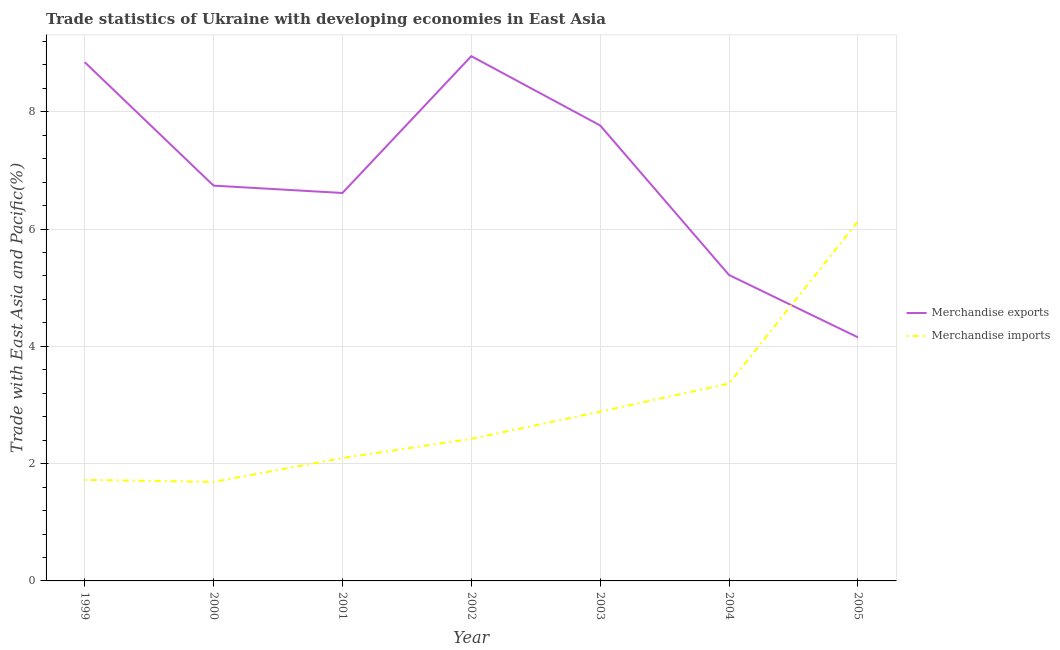How many different coloured lines are there?
Provide a short and direct response. 2. Is the number of lines equal to the number of legend labels?
Keep it short and to the point. Yes. What is the merchandise exports in 2005?
Keep it short and to the point. 4.15. Across all years, what is the maximum merchandise imports?
Your answer should be very brief. 6.13. Across all years, what is the minimum merchandise exports?
Make the answer very short. 4.15. In which year was the merchandise imports maximum?
Your response must be concise. 2005. What is the total merchandise imports in the graph?
Keep it short and to the point. 20.31. What is the difference between the merchandise exports in 2000 and that in 2004?
Offer a terse response. 1.52. What is the difference between the merchandise exports in 2003 and the merchandise imports in 2005?
Provide a short and direct response. 1.64. What is the average merchandise imports per year?
Offer a terse response. 2.9. In the year 2002, what is the difference between the merchandise exports and merchandise imports?
Your answer should be compact. 6.53. What is the ratio of the merchandise imports in 2001 to that in 2004?
Offer a very short reply. 0.62. Is the merchandise imports in 1999 less than that in 2000?
Keep it short and to the point. No. Is the difference between the merchandise exports in 1999 and 2001 greater than the difference between the merchandise imports in 1999 and 2001?
Provide a short and direct response. Yes. What is the difference between the highest and the second highest merchandise imports?
Your answer should be compact. 2.76. What is the difference between the highest and the lowest merchandise imports?
Offer a very short reply. 4.44. Is the sum of the merchandise imports in 2000 and 2003 greater than the maximum merchandise exports across all years?
Provide a succinct answer. No. Are the values on the major ticks of Y-axis written in scientific E-notation?
Offer a very short reply. No. Where does the legend appear in the graph?
Provide a short and direct response. Center right. How are the legend labels stacked?
Offer a very short reply. Vertical. What is the title of the graph?
Give a very brief answer. Trade statistics of Ukraine with developing economies in East Asia. What is the label or title of the Y-axis?
Your answer should be very brief. Trade with East Asia and Pacific(%). What is the Trade with East Asia and Pacific(%) of Merchandise exports in 1999?
Your answer should be very brief. 8.85. What is the Trade with East Asia and Pacific(%) of Merchandise imports in 1999?
Give a very brief answer. 1.72. What is the Trade with East Asia and Pacific(%) in Merchandise exports in 2000?
Give a very brief answer. 6.74. What is the Trade with East Asia and Pacific(%) in Merchandise imports in 2000?
Your answer should be compact. 1.69. What is the Trade with East Asia and Pacific(%) of Merchandise exports in 2001?
Your response must be concise. 6.62. What is the Trade with East Asia and Pacific(%) in Merchandise imports in 2001?
Your answer should be compact. 2.1. What is the Trade with East Asia and Pacific(%) of Merchandise exports in 2002?
Provide a short and direct response. 8.95. What is the Trade with East Asia and Pacific(%) of Merchandise imports in 2002?
Make the answer very short. 2.42. What is the Trade with East Asia and Pacific(%) in Merchandise exports in 2003?
Ensure brevity in your answer.  7.77. What is the Trade with East Asia and Pacific(%) in Merchandise imports in 2003?
Offer a very short reply. 2.89. What is the Trade with East Asia and Pacific(%) in Merchandise exports in 2004?
Your response must be concise. 5.22. What is the Trade with East Asia and Pacific(%) of Merchandise imports in 2004?
Keep it short and to the point. 3.37. What is the Trade with East Asia and Pacific(%) in Merchandise exports in 2005?
Keep it short and to the point. 4.15. What is the Trade with East Asia and Pacific(%) of Merchandise imports in 2005?
Keep it short and to the point. 6.13. Across all years, what is the maximum Trade with East Asia and Pacific(%) in Merchandise exports?
Offer a terse response. 8.95. Across all years, what is the maximum Trade with East Asia and Pacific(%) in Merchandise imports?
Make the answer very short. 6.13. Across all years, what is the minimum Trade with East Asia and Pacific(%) in Merchandise exports?
Your answer should be very brief. 4.15. Across all years, what is the minimum Trade with East Asia and Pacific(%) of Merchandise imports?
Ensure brevity in your answer.  1.69. What is the total Trade with East Asia and Pacific(%) in Merchandise exports in the graph?
Your answer should be compact. 48.29. What is the total Trade with East Asia and Pacific(%) in Merchandise imports in the graph?
Your answer should be very brief. 20.31. What is the difference between the Trade with East Asia and Pacific(%) of Merchandise exports in 1999 and that in 2000?
Ensure brevity in your answer.  2.11. What is the difference between the Trade with East Asia and Pacific(%) of Merchandise imports in 1999 and that in 2000?
Make the answer very short. 0.03. What is the difference between the Trade with East Asia and Pacific(%) of Merchandise exports in 1999 and that in 2001?
Give a very brief answer. 2.23. What is the difference between the Trade with East Asia and Pacific(%) of Merchandise imports in 1999 and that in 2001?
Offer a terse response. -0.37. What is the difference between the Trade with East Asia and Pacific(%) of Merchandise exports in 1999 and that in 2002?
Offer a terse response. -0.1. What is the difference between the Trade with East Asia and Pacific(%) of Merchandise imports in 1999 and that in 2002?
Provide a succinct answer. -0.7. What is the difference between the Trade with East Asia and Pacific(%) in Merchandise exports in 1999 and that in 2003?
Keep it short and to the point. 1.08. What is the difference between the Trade with East Asia and Pacific(%) in Merchandise imports in 1999 and that in 2003?
Ensure brevity in your answer.  -1.16. What is the difference between the Trade with East Asia and Pacific(%) of Merchandise exports in 1999 and that in 2004?
Provide a short and direct response. 3.63. What is the difference between the Trade with East Asia and Pacific(%) of Merchandise imports in 1999 and that in 2004?
Keep it short and to the point. -1.64. What is the difference between the Trade with East Asia and Pacific(%) of Merchandise exports in 1999 and that in 2005?
Your answer should be very brief. 4.69. What is the difference between the Trade with East Asia and Pacific(%) of Merchandise imports in 1999 and that in 2005?
Your response must be concise. -4.41. What is the difference between the Trade with East Asia and Pacific(%) in Merchandise imports in 2000 and that in 2001?
Provide a short and direct response. -0.41. What is the difference between the Trade with East Asia and Pacific(%) in Merchandise exports in 2000 and that in 2002?
Give a very brief answer. -2.21. What is the difference between the Trade with East Asia and Pacific(%) in Merchandise imports in 2000 and that in 2002?
Your answer should be compact. -0.73. What is the difference between the Trade with East Asia and Pacific(%) in Merchandise exports in 2000 and that in 2003?
Ensure brevity in your answer.  -1.03. What is the difference between the Trade with East Asia and Pacific(%) of Merchandise imports in 2000 and that in 2003?
Offer a very short reply. -1.2. What is the difference between the Trade with East Asia and Pacific(%) in Merchandise exports in 2000 and that in 2004?
Your answer should be very brief. 1.52. What is the difference between the Trade with East Asia and Pacific(%) of Merchandise imports in 2000 and that in 2004?
Your answer should be very brief. -1.68. What is the difference between the Trade with East Asia and Pacific(%) of Merchandise exports in 2000 and that in 2005?
Give a very brief answer. 2.59. What is the difference between the Trade with East Asia and Pacific(%) of Merchandise imports in 2000 and that in 2005?
Give a very brief answer. -4.44. What is the difference between the Trade with East Asia and Pacific(%) in Merchandise exports in 2001 and that in 2002?
Your answer should be very brief. -2.33. What is the difference between the Trade with East Asia and Pacific(%) of Merchandise imports in 2001 and that in 2002?
Give a very brief answer. -0.33. What is the difference between the Trade with East Asia and Pacific(%) in Merchandise exports in 2001 and that in 2003?
Your answer should be compact. -1.15. What is the difference between the Trade with East Asia and Pacific(%) of Merchandise imports in 2001 and that in 2003?
Give a very brief answer. -0.79. What is the difference between the Trade with East Asia and Pacific(%) of Merchandise exports in 2001 and that in 2004?
Provide a succinct answer. 1.4. What is the difference between the Trade with East Asia and Pacific(%) of Merchandise imports in 2001 and that in 2004?
Offer a terse response. -1.27. What is the difference between the Trade with East Asia and Pacific(%) of Merchandise exports in 2001 and that in 2005?
Offer a very short reply. 2.46. What is the difference between the Trade with East Asia and Pacific(%) of Merchandise imports in 2001 and that in 2005?
Make the answer very short. -4.04. What is the difference between the Trade with East Asia and Pacific(%) in Merchandise exports in 2002 and that in 2003?
Provide a succinct answer. 1.18. What is the difference between the Trade with East Asia and Pacific(%) of Merchandise imports in 2002 and that in 2003?
Provide a short and direct response. -0.46. What is the difference between the Trade with East Asia and Pacific(%) of Merchandise exports in 2002 and that in 2004?
Offer a very short reply. 3.73. What is the difference between the Trade with East Asia and Pacific(%) of Merchandise imports in 2002 and that in 2004?
Provide a short and direct response. -0.94. What is the difference between the Trade with East Asia and Pacific(%) of Merchandise exports in 2002 and that in 2005?
Offer a very short reply. 4.79. What is the difference between the Trade with East Asia and Pacific(%) in Merchandise imports in 2002 and that in 2005?
Provide a short and direct response. -3.71. What is the difference between the Trade with East Asia and Pacific(%) in Merchandise exports in 2003 and that in 2004?
Keep it short and to the point. 2.55. What is the difference between the Trade with East Asia and Pacific(%) of Merchandise imports in 2003 and that in 2004?
Provide a short and direct response. -0.48. What is the difference between the Trade with East Asia and Pacific(%) of Merchandise exports in 2003 and that in 2005?
Your response must be concise. 3.61. What is the difference between the Trade with East Asia and Pacific(%) in Merchandise imports in 2003 and that in 2005?
Provide a short and direct response. -3.24. What is the difference between the Trade with East Asia and Pacific(%) in Merchandise exports in 2004 and that in 2005?
Provide a short and direct response. 1.06. What is the difference between the Trade with East Asia and Pacific(%) in Merchandise imports in 2004 and that in 2005?
Provide a succinct answer. -2.76. What is the difference between the Trade with East Asia and Pacific(%) of Merchandise exports in 1999 and the Trade with East Asia and Pacific(%) of Merchandise imports in 2000?
Give a very brief answer. 7.16. What is the difference between the Trade with East Asia and Pacific(%) in Merchandise exports in 1999 and the Trade with East Asia and Pacific(%) in Merchandise imports in 2001?
Make the answer very short. 6.75. What is the difference between the Trade with East Asia and Pacific(%) of Merchandise exports in 1999 and the Trade with East Asia and Pacific(%) of Merchandise imports in 2002?
Offer a very short reply. 6.42. What is the difference between the Trade with East Asia and Pacific(%) of Merchandise exports in 1999 and the Trade with East Asia and Pacific(%) of Merchandise imports in 2003?
Keep it short and to the point. 5.96. What is the difference between the Trade with East Asia and Pacific(%) in Merchandise exports in 1999 and the Trade with East Asia and Pacific(%) in Merchandise imports in 2004?
Provide a succinct answer. 5.48. What is the difference between the Trade with East Asia and Pacific(%) of Merchandise exports in 1999 and the Trade with East Asia and Pacific(%) of Merchandise imports in 2005?
Keep it short and to the point. 2.72. What is the difference between the Trade with East Asia and Pacific(%) of Merchandise exports in 2000 and the Trade with East Asia and Pacific(%) of Merchandise imports in 2001?
Your answer should be very brief. 4.65. What is the difference between the Trade with East Asia and Pacific(%) of Merchandise exports in 2000 and the Trade with East Asia and Pacific(%) of Merchandise imports in 2002?
Provide a succinct answer. 4.32. What is the difference between the Trade with East Asia and Pacific(%) in Merchandise exports in 2000 and the Trade with East Asia and Pacific(%) in Merchandise imports in 2003?
Provide a succinct answer. 3.85. What is the difference between the Trade with East Asia and Pacific(%) in Merchandise exports in 2000 and the Trade with East Asia and Pacific(%) in Merchandise imports in 2004?
Your response must be concise. 3.37. What is the difference between the Trade with East Asia and Pacific(%) in Merchandise exports in 2000 and the Trade with East Asia and Pacific(%) in Merchandise imports in 2005?
Your answer should be compact. 0.61. What is the difference between the Trade with East Asia and Pacific(%) in Merchandise exports in 2001 and the Trade with East Asia and Pacific(%) in Merchandise imports in 2002?
Offer a very short reply. 4.19. What is the difference between the Trade with East Asia and Pacific(%) in Merchandise exports in 2001 and the Trade with East Asia and Pacific(%) in Merchandise imports in 2003?
Your answer should be compact. 3.73. What is the difference between the Trade with East Asia and Pacific(%) in Merchandise exports in 2001 and the Trade with East Asia and Pacific(%) in Merchandise imports in 2004?
Your response must be concise. 3.25. What is the difference between the Trade with East Asia and Pacific(%) in Merchandise exports in 2001 and the Trade with East Asia and Pacific(%) in Merchandise imports in 2005?
Your answer should be very brief. 0.48. What is the difference between the Trade with East Asia and Pacific(%) in Merchandise exports in 2002 and the Trade with East Asia and Pacific(%) in Merchandise imports in 2003?
Keep it short and to the point. 6.06. What is the difference between the Trade with East Asia and Pacific(%) of Merchandise exports in 2002 and the Trade with East Asia and Pacific(%) of Merchandise imports in 2004?
Your answer should be compact. 5.58. What is the difference between the Trade with East Asia and Pacific(%) of Merchandise exports in 2002 and the Trade with East Asia and Pacific(%) of Merchandise imports in 2005?
Provide a short and direct response. 2.82. What is the difference between the Trade with East Asia and Pacific(%) of Merchandise exports in 2003 and the Trade with East Asia and Pacific(%) of Merchandise imports in 2004?
Provide a succinct answer. 4.4. What is the difference between the Trade with East Asia and Pacific(%) of Merchandise exports in 2003 and the Trade with East Asia and Pacific(%) of Merchandise imports in 2005?
Your answer should be compact. 1.64. What is the difference between the Trade with East Asia and Pacific(%) of Merchandise exports in 2004 and the Trade with East Asia and Pacific(%) of Merchandise imports in 2005?
Make the answer very short. -0.91. What is the average Trade with East Asia and Pacific(%) in Merchandise exports per year?
Your answer should be very brief. 6.9. What is the average Trade with East Asia and Pacific(%) of Merchandise imports per year?
Your answer should be very brief. 2.9. In the year 1999, what is the difference between the Trade with East Asia and Pacific(%) of Merchandise exports and Trade with East Asia and Pacific(%) of Merchandise imports?
Provide a short and direct response. 7.12. In the year 2000, what is the difference between the Trade with East Asia and Pacific(%) in Merchandise exports and Trade with East Asia and Pacific(%) in Merchandise imports?
Provide a succinct answer. 5.05. In the year 2001, what is the difference between the Trade with East Asia and Pacific(%) in Merchandise exports and Trade with East Asia and Pacific(%) in Merchandise imports?
Ensure brevity in your answer.  4.52. In the year 2002, what is the difference between the Trade with East Asia and Pacific(%) in Merchandise exports and Trade with East Asia and Pacific(%) in Merchandise imports?
Offer a terse response. 6.53. In the year 2003, what is the difference between the Trade with East Asia and Pacific(%) of Merchandise exports and Trade with East Asia and Pacific(%) of Merchandise imports?
Provide a succinct answer. 4.88. In the year 2004, what is the difference between the Trade with East Asia and Pacific(%) in Merchandise exports and Trade with East Asia and Pacific(%) in Merchandise imports?
Your answer should be compact. 1.85. In the year 2005, what is the difference between the Trade with East Asia and Pacific(%) in Merchandise exports and Trade with East Asia and Pacific(%) in Merchandise imports?
Offer a very short reply. -1.98. What is the ratio of the Trade with East Asia and Pacific(%) in Merchandise exports in 1999 to that in 2000?
Offer a terse response. 1.31. What is the ratio of the Trade with East Asia and Pacific(%) of Merchandise imports in 1999 to that in 2000?
Your response must be concise. 1.02. What is the ratio of the Trade with East Asia and Pacific(%) of Merchandise exports in 1999 to that in 2001?
Your response must be concise. 1.34. What is the ratio of the Trade with East Asia and Pacific(%) in Merchandise imports in 1999 to that in 2001?
Provide a short and direct response. 0.82. What is the ratio of the Trade with East Asia and Pacific(%) of Merchandise imports in 1999 to that in 2002?
Give a very brief answer. 0.71. What is the ratio of the Trade with East Asia and Pacific(%) of Merchandise exports in 1999 to that in 2003?
Ensure brevity in your answer.  1.14. What is the ratio of the Trade with East Asia and Pacific(%) of Merchandise imports in 1999 to that in 2003?
Keep it short and to the point. 0.6. What is the ratio of the Trade with East Asia and Pacific(%) of Merchandise exports in 1999 to that in 2004?
Offer a very short reply. 1.7. What is the ratio of the Trade with East Asia and Pacific(%) of Merchandise imports in 1999 to that in 2004?
Your response must be concise. 0.51. What is the ratio of the Trade with East Asia and Pacific(%) of Merchandise exports in 1999 to that in 2005?
Keep it short and to the point. 2.13. What is the ratio of the Trade with East Asia and Pacific(%) of Merchandise imports in 1999 to that in 2005?
Offer a very short reply. 0.28. What is the ratio of the Trade with East Asia and Pacific(%) of Merchandise exports in 2000 to that in 2001?
Provide a succinct answer. 1.02. What is the ratio of the Trade with East Asia and Pacific(%) of Merchandise imports in 2000 to that in 2001?
Ensure brevity in your answer.  0.81. What is the ratio of the Trade with East Asia and Pacific(%) in Merchandise exports in 2000 to that in 2002?
Provide a short and direct response. 0.75. What is the ratio of the Trade with East Asia and Pacific(%) in Merchandise imports in 2000 to that in 2002?
Offer a very short reply. 0.7. What is the ratio of the Trade with East Asia and Pacific(%) in Merchandise exports in 2000 to that in 2003?
Give a very brief answer. 0.87. What is the ratio of the Trade with East Asia and Pacific(%) in Merchandise imports in 2000 to that in 2003?
Your answer should be very brief. 0.59. What is the ratio of the Trade with East Asia and Pacific(%) in Merchandise exports in 2000 to that in 2004?
Your answer should be compact. 1.29. What is the ratio of the Trade with East Asia and Pacific(%) in Merchandise imports in 2000 to that in 2004?
Give a very brief answer. 0.5. What is the ratio of the Trade with East Asia and Pacific(%) in Merchandise exports in 2000 to that in 2005?
Provide a succinct answer. 1.62. What is the ratio of the Trade with East Asia and Pacific(%) in Merchandise imports in 2000 to that in 2005?
Keep it short and to the point. 0.28. What is the ratio of the Trade with East Asia and Pacific(%) of Merchandise exports in 2001 to that in 2002?
Make the answer very short. 0.74. What is the ratio of the Trade with East Asia and Pacific(%) in Merchandise imports in 2001 to that in 2002?
Ensure brevity in your answer.  0.87. What is the ratio of the Trade with East Asia and Pacific(%) of Merchandise exports in 2001 to that in 2003?
Offer a terse response. 0.85. What is the ratio of the Trade with East Asia and Pacific(%) in Merchandise imports in 2001 to that in 2003?
Your answer should be very brief. 0.73. What is the ratio of the Trade with East Asia and Pacific(%) of Merchandise exports in 2001 to that in 2004?
Give a very brief answer. 1.27. What is the ratio of the Trade with East Asia and Pacific(%) of Merchandise imports in 2001 to that in 2004?
Ensure brevity in your answer.  0.62. What is the ratio of the Trade with East Asia and Pacific(%) in Merchandise exports in 2001 to that in 2005?
Keep it short and to the point. 1.59. What is the ratio of the Trade with East Asia and Pacific(%) in Merchandise imports in 2001 to that in 2005?
Keep it short and to the point. 0.34. What is the ratio of the Trade with East Asia and Pacific(%) of Merchandise exports in 2002 to that in 2003?
Make the answer very short. 1.15. What is the ratio of the Trade with East Asia and Pacific(%) of Merchandise imports in 2002 to that in 2003?
Give a very brief answer. 0.84. What is the ratio of the Trade with East Asia and Pacific(%) of Merchandise exports in 2002 to that in 2004?
Your answer should be compact. 1.72. What is the ratio of the Trade with East Asia and Pacific(%) of Merchandise imports in 2002 to that in 2004?
Keep it short and to the point. 0.72. What is the ratio of the Trade with East Asia and Pacific(%) of Merchandise exports in 2002 to that in 2005?
Offer a terse response. 2.15. What is the ratio of the Trade with East Asia and Pacific(%) of Merchandise imports in 2002 to that in 2005?
Your response must be concise. 0.4. What is the ratio of the Trade with East Asia and Pacific(%) of Merchandise exports in 2003 to that in 2004?
Your response must be concise. 1.49. What is the ratio of the Trade with East Asia and Pacific(%) in Merchandise imports in 2003 to that in 2004?
Provide a short and direct response. 0.86. What is the ratio of the Trade with East Asia and Pacific(%) of Merchandise exports in 2003 to that in 2005?
Ensure brevity in your answer.  1.87. What is the ratio of the Trade with East Asia and Pacific(%) of Merchandise imports in 2003 to that in 2005?
Give a very brief answer. 0.47. What is the ratio of the Trade with East Asia and Pacific(%) of Merchandise exports in 2004 to that in 2005?
Provide a succinct answer. 1.26. What is the ratio of the Trade with East Asia and Pacific(%) of Merchandise imports in 2004 to that in 2005?
Keep it short and to the point. 0.55. What is the difference between the highest and the second highest Trade with East Asia and Pacific(%) of Merchandise exports?
Your answer should be compact. 0.1. What is the difference between the highest and the second highest Trade with East Asia and Pacific(%) in Merchandise imports?
Offer a terse response. 2.76. What is the difference between the highest and the lowest Trade with East Asia and Pacific(%) of Merchandise exports?
Make the answer very short. 4.79. What is the difference between the highest and the lowest Trade with East Asia and Pacific(%) of Merchandise imports?
Provide a succinct answer. 4.44. 